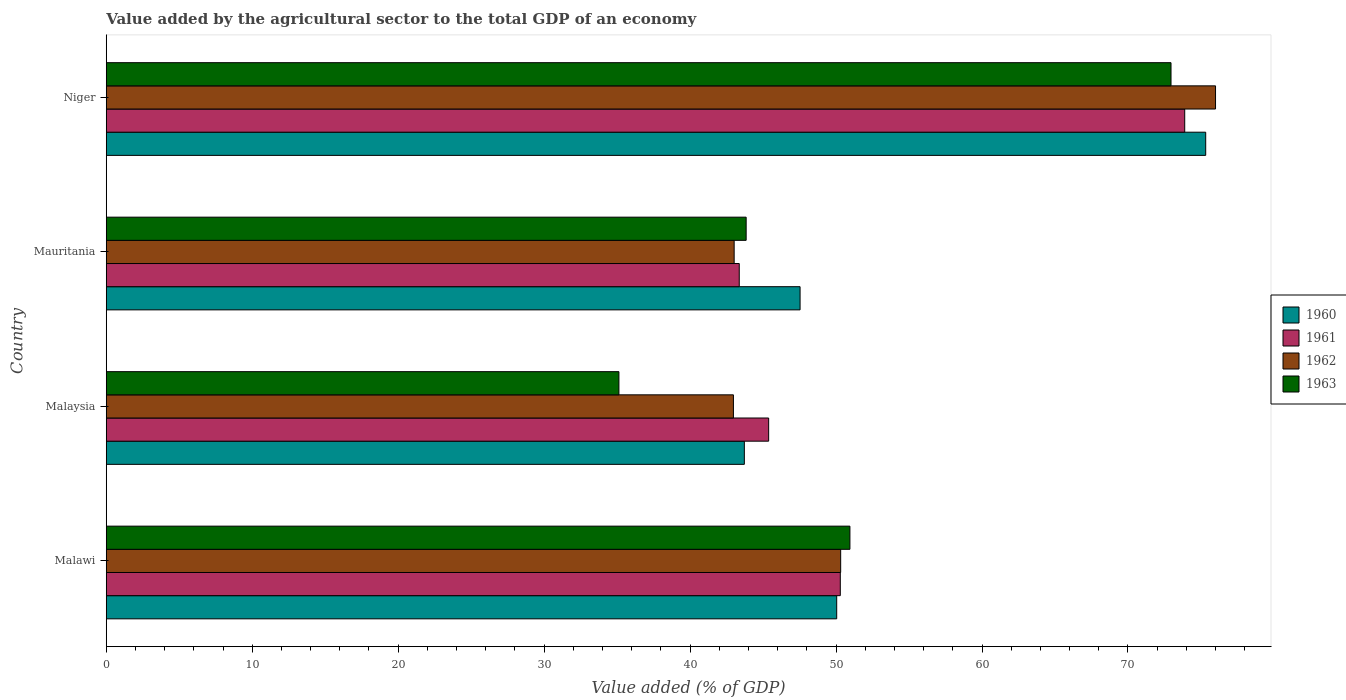How many different coloured bars are there?
Ensure brevity in your answer.  4. How many bars are there on the 3rd tick from the top?
Keep it short and to the point. 4. What is the label of the 1st group of bars from the top?
Provide a short and direct response. Niger. In how many cases, is the number of bars for a given country not equal to the number of legend labels?
Offer a very short reply. 0. What is the value added by the agricultural sector to the total GDP in 1961 in Malaysia?
Ensure brevity in your answer.  45.38. Across all countries, what is the maximum value added by the agricultural sector to the total GDP in 1962?
Ensure brevity in your answer.  76. Across all countries, what is the minimum value added by the agricultural sector to the total GDP in 1960?
Keep it short and to the point. 43.72. In which country was the value added by the agricultural sector to the total GDP in 1960 maximum?
Your answer should be compact. Niger. In which country was the value added by the agricultural sector to the total GDP in 1963 minimum?
Ensure brevity in your answer.  Malaysia. What is the total value added by the agricultural sector to the total GDP in 1962 in the graph?
Offer a very short reply. 212.3. What is the difference between the value added by the agricultural sector to the total GDP in 1962 in Mauritania and that in Niger?
Your response must be concise. -32.98. What is the difference between the value added by the agricultural sector to the total GDP in 1963 in Malaysia and the value added by the agricultural sector to the total GDP in 1961 in Mauritania?
Ensure brevity in your answer.  -8.24. What is the average value added by the agricultural sector to the total GDP in 1962 per country?
Keep it short and to the point. 53.08. What is the difference between the value added by the agricultural sector to the total GDP in 1961 and value added by the agricultural sector to the total GDP in 1962 in Malaysia?
Offer a terse response. 2.41. What is the ratio of the value added by the agricultural sector to the total GDP in 1961 in Malawi to that in Mauritania?
Make the answer very short. 1.16. Is the value added by the agricultural sector to the total GDP in 1963 in Mauritania less than that in Niger?
Keep it short and to the point. Yes. Is the difference between the value added by the agricultural sector to the total GDP in 1961 in Mauritania and Niger greater than the difference between the value added by the agricultural sector to the total GDP in 1962 in Mauritania and Niger?
Your answer should be compact. Yes. What is the difference between the highest and the second highest value added by the agricultural sector to the total GDP in 1963?
Offer a very short reply. 22. What is the difference between the highest and the lowest value added by the agricultural sector to the total GDP in 1962?
Ensure brevity in your answer.  33.03. In how many countries, is the value added by the agricultural sector to the total GDP in 1962 greater than the average value added by the agricultural sector to the total GDP in 1962 taken over all countries?
Offer a very short reply. 1. Is the sum of the value added by the agricultural sector to the total GDP in 1962 in Malawi and Niger greater than the maximum value added by the agricultural sector to the total GDP in 1960 across all countries?
Provide a short and direct response. Yes. What does the 1st bar from the top in Niger represents?
Make the answer very short. 1963. How many bars are there?
Your answer should be very brief. 16. How many countries are there in the graph?
Offer a very short reply. 4. What is the difference between two consecutive major ticks on the X-axis?
Your answer should be compact. 10. Does the graph contain grids?
Provide a short and direct response. No. How many legend labels are there?
Your answer should be very brief. 4. What is the title of the graph?
Your response must be concise. Value added by the agricultural sector to the total GDP of an economy. What is the label or title of the X-axis?
Offer a terse response. Value added (% of GDP). What is the Value added (% of GDP) in 1960 in Malawi?
Give a very brief answer. 50.04. What is the Value added (% of GDP) of 1961 in Malawi?
Provide a succinct answer. 50.29. What is the Value added (% of GDP) of 1962 in Malawi?
Your answer should be compact. 50.32. What is the Value added (% of GDP) of 1963 in Malawi?
Provide a short and direct response. 50.95. What is the Value added (% of GDP) in 1960 in Malaysia?
Keep it short and to the point. 43.72. What is the Value added (% of GDP) in 1961 in Malaysia?
Give a very brief answer. 45.38. What is the Value added (% of GDP) of 1962 in Malaysia?
Keep it short and to the point. 42.97. What is the Value added (% of GDP) of 1963 in Malaysia?
Your answer should be compact. 35.12. What is the Value added (% of GDP) of 1960 in Mauritania?
Your response must be concise. 47.53. What is the Value added (% of GDP) of 1961 in Mauritania?
Offer a very short reply. 43.37. What is the Value added (% of GDP) of 1962 in Mauritania?
Your answer should be compact. 43.02. What is the Value added (% of GDP) in 1963 in Mauritania?
Provide a succinct answer. 43.84. What is the Value added (% of GDP) of 1960 in Niger?
Offer a terse response. 75.32. What is the Value added (% of GDP) of 1961 in Niger?
Offer a terse response. 73.89. What is the Value added (% of GDP) of 1962 in Niger?
Give a very brief answer. 76. What is the Value added (% of GDP) in 1963 in Niger?
Give a very brief answer. 72.95. Across all countries, what is the maximum Value added (% of GDP) in 1960?
Give a very brief answer. 75.32. Across all countries, what is the maximum Value added (% of GDP) of 1961?
Offer a terse response. 73.89. Across all countries, what is the maximum Value added (% of GDP) of 1962?
Make the answer very short. 76. Across all countries, what is the maximum Value added (% of GDP) of 1963?
Ensure brevity in your answer.  72.95. Across all countries, what is the minimum Value added (% of GDP) of 1960?
Make the answer very short. 43.72. Across all countries, what is the minimum Value added (% of GDP) of 1961?
Make the answer very short. 43.37. Across all countries, what is the minimum Value added (% of GDP) in 1962?
Provide a short and direct response. 42.97. Across all countries, what is the minimum Value added (% of GDP) in 1963?
Make the answer very short. 35.12. What is the total Value added (% of GDP) of 1960 in the graph?
Give a very brief answer. 216.62. What is the total Value added (% of GDP) in 1961 in the graph?
Keep it short and to the point. 212.93. What is the total Value added (% of GDP) in 1962 in the graph?
Offer a very short reply. 212.3. What is the total Value added (% of GDP) in 1963 in the graph?
Your response must be concise. 202.86. What is the difference between the Value added (% of GDP) in 1960 in Malawi and that in Malaysia?
Your answer should be compact. 6.33. What is the difference between the Value added (% of GDP) in 1961 in Malawi and that in Malaysia?
Give a very brief answer. 4.91. What is the difference between the Value added (% of GDP) in 1962 in Malawi and that in Malaysia?
Offer a very short reply. 7.35. What is the difference between the Value added (% of GDP) of 1963 in Malawi and that in Malaysia?
Your answer should be very brief. 15.83. What is the difference between the Value added (% of GDP) of 1960 in Malawi and that in Mauritania?
Offer a terse response. 2.51. What is the difference between the Value added (% of GDP) in 1961 in Malawi and that in Mauritania?
Ensure brevity in your answer.  6.92. What is the difference between the Value added (% of GDP) in 1962 in Malawi and that in Mauritania?
Give a very brief answer. 7.3. What is the difference between the Value added (% of GDP) of 1963 in Malawi and that in Mauritania?
Your response must be concise. 7.11. What is the difference between the Value added (% of GDP) in 1960 in Malawi and that in Niger?
Give a very brief answer. -25.28. What is the difference between the Value added (% of GDP) in 1961 in Malawi and that in Niger?
Ensure brevity in your answer.  -23.6. What is the difference between the Value added (% of GDP) in 1962 in Malawi and that in Niger?
Give a very brief answer. -25.68. What is the difference between the Value added (% of GDP) in 1963 in Malawi and that in Niger?
Your answer should be very brief. -22. What is the difference between the Value added (% of GDP) of 1960 in Malaysia and that in Mauritania?
Give a very brief answer. -3.82. What is the difference between the Value added (% of GDP) in 1961 in Malaysia and that in Mauritania?
Ensure brevity in your answer.  2.01. What is the difference between the Value added (% of GDP) in 1962 in Malaysia and that in Mauritania?
Offer a very short reply. -0.05. What is the difference between the Value added (% of GDP) of 1963 in Malaysia and that in Mauritania?
Offer a very short reply. -8.72. What is the difference between the Value added (% of GDP) in 1960 in Malaysia and that in Niger?
Your answer should be very brief. -31.61. What is the difference between the Value added (% of GDP) of 1961 in Malaysia and that in Niger?
Your answer should be very brief. -28.5. What is the difference between the Value added (% of GDP) of 1962 in Malaysia and that in Niger?
Provide a short and direct response. -33.03. What is the difference between the Value added (% of GDP) of 1963 in Malaysia and that in Niger?
Offer a very short reply. -37.82. What is the difference between the Value added (% of GDP) in 1960 in Mauritania and that in Niger?
Make the answer very short. -27.79. What is the difference between the Value added (% of GDP) in 1961 in Mauritania and that in Niger?
Keep it short and to the point. -30.52. What is the difference between the Value added (% of GDP) of 1962 in Mauritania and that in Niger?
Offer a very short reply. -32.98. What is the difference between the Value added (% of GDP) of 1963 in Mauritania and that in Niger?
Offer a very short reply. -29.11. What is the difference between the Value added (% of GDP) in 1960 in Malawi and the Value added (% of GDP) in 1961 in Malaysia?
Provide a short and direct response. 4.66. What is the difference between the Value added (% of GDP) of 1960 in Malawi and the Value added (% of GDP) of 1962 in Malaysia?
Ensure brevity in your answer.  7.08. What is the difference between the Value added (% of GDP) in 1960 in Malawi and the Value added (% of GDP) in 1963 in Malaysia?
Provide a succinct answer. 14.92. What is the difference between the Value added (% of GDP) of 1961 in Malawi and the Value added (% of GDP) of 1962 in Malaysia?
Ensure brevity in your answer.  7.32. What is the difference between the Value added (% of GDP) in 1961 in Malawi and the Value added (% of GDP) in 1963 in Malaysia?
Provide a short and direct response. 15.17. What is the difference between the Value added (% of GDP) in 1962 in Malawi and the Value added (% of GDP) in 1963 in Malaysia?
Ensure brevity in your answer.  15.19. What is the difference between the Value added (% of GDP) in 1960 in Malawi and the Value added (% of GDP) in 1961 in Mauritania?
Your answer should be very brief. 6.68. What is the difference between the Value added (% of GDP) in 1960 in Malawi and the Value added (% of GDP) in 1962 in Mauritania?
Your answer should be compact. 7.03. What is the difference between the Value added (% of GDP) of 1960 in Malawi and the Value added (% of GDP) of 1963 in Mauritania?
Make the answer very short. 6.2. What is the difference between the Value added (% of GDP) of 1961 in Malawi and the Value added (% of GDP) of 1962 in Mauritania?
Your answer should be compact. 7.27. What is the difference between the Value added (% of GDP) in 1961 in Malawi and the Value added (% of GDP) in 1963 in Mauritania?
Your answer should be very brief. 6.45. What is the difference between the Value added (% of GDP) of 1962 in Malawi and the Value added (% of GDP) of 1963 in Mauritania?
Provide a succinct answer. 6.48. What is the difference between the Value added (% of GDP) in 1960 in Malawi and the Value added (% of GDP) in 1961 in Niger?
Provide a succinct answer. -23.84. What is the difference between the Value added (% of GDP) of 1960 in Malawi and the Value added (% of GDP) of 1962 in Niger?
Offer a very short reply. -25.95. What is the difference between the Value added (% of GDP) of 1960 in Malawi and the Value added (% of GDP) of 1963 in Niger?
Your response must be concise. -22.9. What is the difference between the Value added (% of GDP) in 1961 in Malawi and the Value added (% of GDP) in 1962 in Niger?
Make the answer very short. -25.71. What is the difference between the Value added (% of GDP) of 1961 in Malawi and the Value added (% of GDP) of 1963 in Niger?
Offer a terse response. -22.66. What is the difference between the Value added (% of GDP) of 1962 in Malawi and the Value added (% of GDP) of 1963 in Niger?
Offer a very short reply. -22.63. What is the difference between the Value added (% of GDP) in 1960 in Malaysia and the Value added (% of GDP) in 1961 in Mauritania?
Provide a succinct answer. 0.35. What is the difference between the Value added (% of GDP) in 1960 in Malaysia and the Value added (% of GDP) in 1962 in Mauritania?
Give a very brief answer. 0.7. What is the difference between the Value added (% of GDP) in 1960 in Malaysia and the Value added (% of GDP) in 1963 in Mauritania?
Ensure brevity in your answer.  -0.12. What is the difference between the Value added (% of GDP) of 1961 in Malaysia and the Value added (% of GDP) of 1962 in Mauritania?
Ensure brevity in your answer.  2.36. What is the difference between the Value added (% of GDP) in 1961 in Malaysia and the Value added (% of GDP) in 1963 in Mauritania?
Your response must be concise. 1.54. What is the difference between the Value added (% of GDP) of 1962 in Malaysia and the Value added (% of GDP) of 1963 in Mauritania?
Offer a terse response. -0.87. What is the difference between the Value added (% of GDP) in 1960 in Malaysia and the Value added (% of GDP) in 1961 in Niger?
Make the answer very short. -30.17. What is the difference between the Value added (% of GDP) of 1960 in Malaysia and the Value added (% of GDP) of 1962 in Niger?
Ensure brevity in your answer.  -32.28. What is the difference between the Value added (% of GDP) in 1960 in Malaysia and the Value added (% of GDP) in 1963 in Niger?
Provide a short and direct response. -29.23. What is the difference between the Value added (% of GDP) of 1961 in Malaysia and the Value added (% of GDP) of 1962 in Niger?
Make the answer very short. -30.62. What is the difference between the Value added (% of GDP) of 1961 in Malaysia and the Value added (% of GDP) of 1963 in Niger?
Your answer should be very brief. -27.57. What is the difference between the Value added (% of GDP) in 1962 in Malaysia and the Value added (% of GDP) in 1963 in Niger?
Offer a very short reply. -29.98. What is the difference between the Value added (% of GDP) of 1960 in Mauritania and the Value added (% of GDP) of 1961 in Niger?
Your response must be concise. -26.35. What is the difference between the Value added (% of GDP) in 1960 in Mauritania and the Value added (% of GDP) in 1962 in Niger?
Offer a terse response. -28.46. What is the difference between the Value added (% of GDP) in 1960 in Mauritania and the Value added (% of GDP) in 1963 in Niger?
Your response must be concise. -25.41. What is the difference between the Value added (% of GDP) of 1961 in Mauritania and the Value added (% of GDP) of 1962 in Niger?
Your answer should be compact. -32.63. What is the difference between the Value added (% of GDP) of 1961 in Mauritania and the Value added (% of GDP) of 1963 in Niger?
Offer a terse response. -29.58. What is the difference between the Value added (% of GDP) in 1962 in Mauritania and the Value added (% of GDP) in 1963 in Niger?
Offer a very short reply. -29.93. What is the average Value added (% of GDP) of 1960 per country?
Your answer should be compact. 54.15. What is the average Value added (% of GDP) in 1961 per country?
Your response must be concise. 53.23. What is the average Value added (% of GDP) in 1962 per country?
Provide a succinct answer. 53.08. What is the average Value added (% of GDP) in 1963 per country?
Offer a very short reply. 50.72. What is the difference between the Value added (% of GDP) in 1960 and Value added (% of GDP) in 1961 in Malawi?
Give a very brief answer. -0.25. What is the difference between the Value added (% of GDP) in 1960 and Value added (% of GDP) in 1962 in Malawi?
Offer a terse response. -0.27. What is the difference between the Value added (% of GDP) in 1960 and Value added (% of GDP) in 1963 in Malawi?
Ensure brevity in your answer.  -0.9. What is the difference between the Value added (% of GDP) in 1961 and Value added (% of GDP) in 1962 in Malawi?
Offer a terse response. -0.03. What is the difference between the Value added (% of GDP) in 1961 and Value added (% of GDP) in 1963 in Malawi?
Your response must be concise. -0.66. What is the difference between the Value added (% of GDP) in 1962 and Value added (% of GDP) in 1963 in Malawi?
Offer a terse response. -0.63. What is the difference between the Value added (% of GDP) in 1960 and Value added (% of GDP) in 1961 in Malaysia?
Offer a terse response. -1.67. What is the difference between the Value added (% of GDP) in 1960 and Value added (% of GDP) in 1962 in Malaysia?
Provide a short and direct response. 0.75. What is the difference between the Value added (% of GDP) of 1960 and Value added (% of GDP) of 1963 in Malaysia?
Offer a terse response. 8.59. What is the difference between the Value added (% of GDP) in 1961 and Value added (% of GDP) in 1962 in Malaysia?
Give a very brief answer. 2.41. What is the difference between the Value added (% of GDP) in 1961 and Value added (% of GDP) in 1963 in Malaysia?
Give a very brief answer. 10.26. What is the difference between the Value added (% of GDP) in 1962 and Value added (% of GDP) in 1963 in Malaysia?
Your answer should be very brief. 7.84. What is the difference between the Value added (% of GDP) in 1960 and Value added (% of GDP) in 1961 in Mauritania?
Your response must be concise. 4.17. What is the difference between the Value added (% of GDP) in 1960 and Value added (% of GDP) in 1962 in Mauritania?
Keep it short and to the point. 4.52. What is the difference between the Value added (% of GDP) in 1960 and Value added (% of GDP) in 1963 in Mauritania?
Provide a short and direct response. 3.69. What is the difference between the Value added (% of GDP) of 1961 and Value added (% of GDP) of 1962 in Mauritania?
Provide a short and direct response. 0.35. What is the difference between the Value added (% of GDP) of 1961 and Value added (% of GDP) of 1963 in Mauritania?
Your answer should be compact. -0.47. What is the difference between the Value added (% of GDP) in 1962 and Value added (% of GDP) in 1963 in Mauritania?
Make the answer very short. -0.82. What is the difference between the Value added (% of GDP) in 1960 and Value added (% of GDP) in 1961 in Niger?
Offer a terse response. 1.44. What is the difference between the Value added (% of GDP) in 1960 and Value added (% of GDP) in 1962 in Niger?
Your answer should be very brief. -0.67. What is the difference between the Value added (% of GDP) of 1960 and Value added (% of GDP) of 1963 in Niger?
Provide a succinct answer. 2.38. What is the difference between the Value added (% of GDP) in 1961 and Value added (% of GDP) in 1962 in Niger?
Offer a terse response. -2.11. What is the difference between the Value added (% of GDP) of 1961 and Value added (% of GDP) of 1963 in Niger?
Your answer should be very brief. 0.94. What is the difference between the Value added (% of GDP) in 1962 and Value added (% of GDP) in 1963 in Niger?
Give a very brief answer. 3.05. What is the ratio of the Value added (% of GDP) of 1960 in Malawi to that in Malaysia?
Your response must be concise. 1.14. What is the ratio of the Value added (% of GDP) in 1961 in Malawi to that in Malaysia?
Provide a short and direct response. 1.11. What is the ratio of the Value added (% of GDP) in 1962 in Malawi to that in Malaysia?
Give a very brief answer. 1.17. What is the ratio of the Value added (% of GDP) of 1963 in Malawi to that in Malaysia?
Give a very brief answer. 1.45. What is the ratio of the Value added (% of GDP) of 1960 in Malawi to that in Mauritania?
Your response must be concise. 1.05. What is the ratio of the Value added (% of GDP) in 1961 in Malawi to that in Mauritania?
Make the answer very short. 1.16. What is the ratio of the Value added (% of GDP) in 1962 in Malawi to that in Mauritania?
Your response must be concise. 1.17. What is the ratio of the Value added (% of GDP) in 1963 in Malawi to that in Mauritania?
Keep it short and to the point. 1.16. What is the ratio of the Value added (% of GDP) in 1960 in Malawi to that in Niger?
Offer a terse response. 0.66. What is the ratio of the Value added (% of GDP) in 1961 in Malawi to that in Niger?
Your answer should be very brief. 0.68. What is the ratio of the Value added (% of GDP) of 1962 in Malawi to that in Niger?
Make the answer very short. 0.66. What is the ratio of the Value added (% of GDP) of 1963 in Malawi to that in Niger?
Make the answer very short. 0.7. What is the ratio of the Value added (% of GDP) of 1960 in Malaysia to that in Mauritania?
Provide a succinct answer. 0.92. What is the ratio of the Value added (% of GDP) in 1961 in Malaysia to that in Mauritania?
Your answer should be compact. 1.05. What is the ratio of the Value added (% of GDP) of 1963 in Malaysia to that in Mauritania?
Ensure brevity in your answer.  0.8. What is the ratio of the Value added (% of GDP) of 1960 in Malaysia to that in Niger?
Offer a terse response. 0.58. What is the ratio of the Value added (% of GDP) in 1961 in Malaysia to that in Niger?
Offer a terse response. 0.61. What is the ratio of the Value added (% of GDP) in 1962 in Malaysia to that in Niger?
Provide a short and direct response. 0.57. What is the ratio of the Value added (% of GDP) of 1963 in Malaysia to that in Niger?
Your answer should be compact. 0.48. What is the ratio of the Value added (% of GDP) in 1960 in Mauritania to that in Niger?
Your response must be concise. 0.63. What is the ratio of the Value added (% of GDP) of 1961 in Mauritania to that in Niger?
Ensure brevity in your answer.  0.59. What is the ratio of the Value added (% of GDP) of 1962 in Mauritania to that in Niger?
Keep it short and to the point. 0.57. What is the ratio of the Value added (% of GDP) in 1963 in Mauritania to that in Niger?
Keep it short and to the point. 0.6. What is the difference between the highest and the second highest Value added (% of GDP) of 1960?
Keep it short and to the point. 25.28. What is the difference between the highest and the second highest Value added (% of GDP) of 1961?
Give a very brief answer. 23.6. What is the difference between the highest and the second highest Value added (% of GDP) of 1962?
Keep it short and to the point. 25.68. What is the difference between the highest and the second highest Value added (% of GDP) of 1963?
Your answer should be compact. 22. What is the difference between the highest and the lowest Value added (% of GDP) in 1960?
Provide a succinct answer. 31.61. What is the difference between the highest and the lowest Value added (% of GDP) in 1961?
Ensure brevity in your answer.  30.52. What is the difference between the highest and the lowest Value added (% of GDP) of 1962?
Keep it short and to the point. 33.03. What is the difference between the highest and the lowest Value added (% of GDP) of 1963?
Provide a short and direct response. 37.82. 